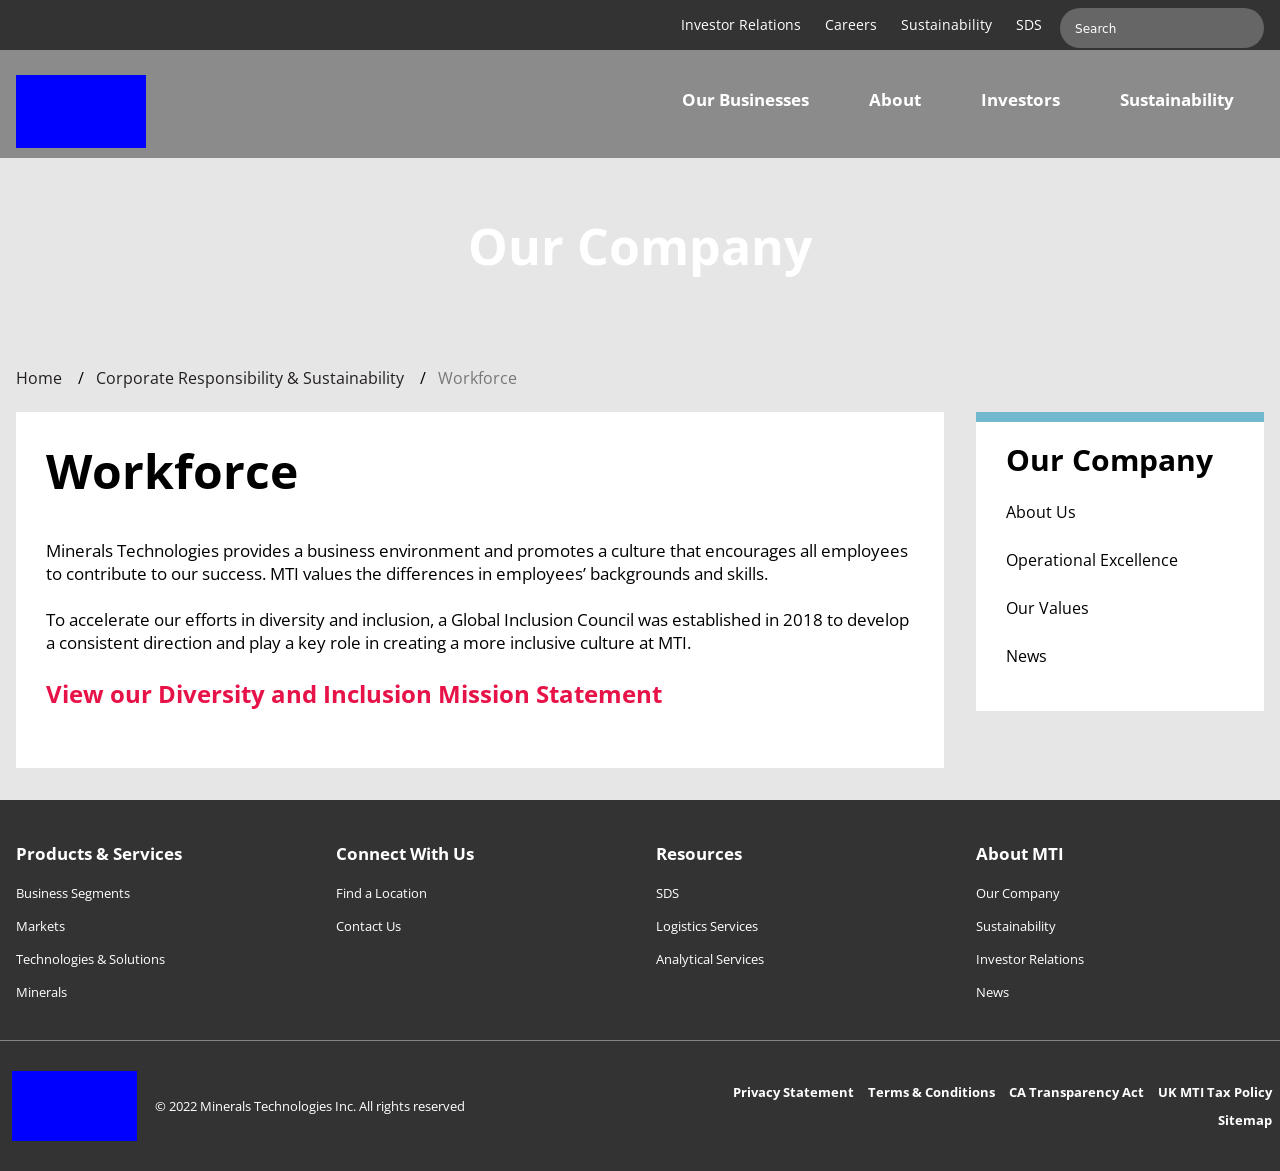What can be inferred about the company's commitment to sustainability from the website image? From the website image, it is visible that the company places value on sustainability, as it is prominently featured alongside other main navigation items like Careers and SDS. This suggests that sustainability is a significant aspect of their corporate identity and operations. 